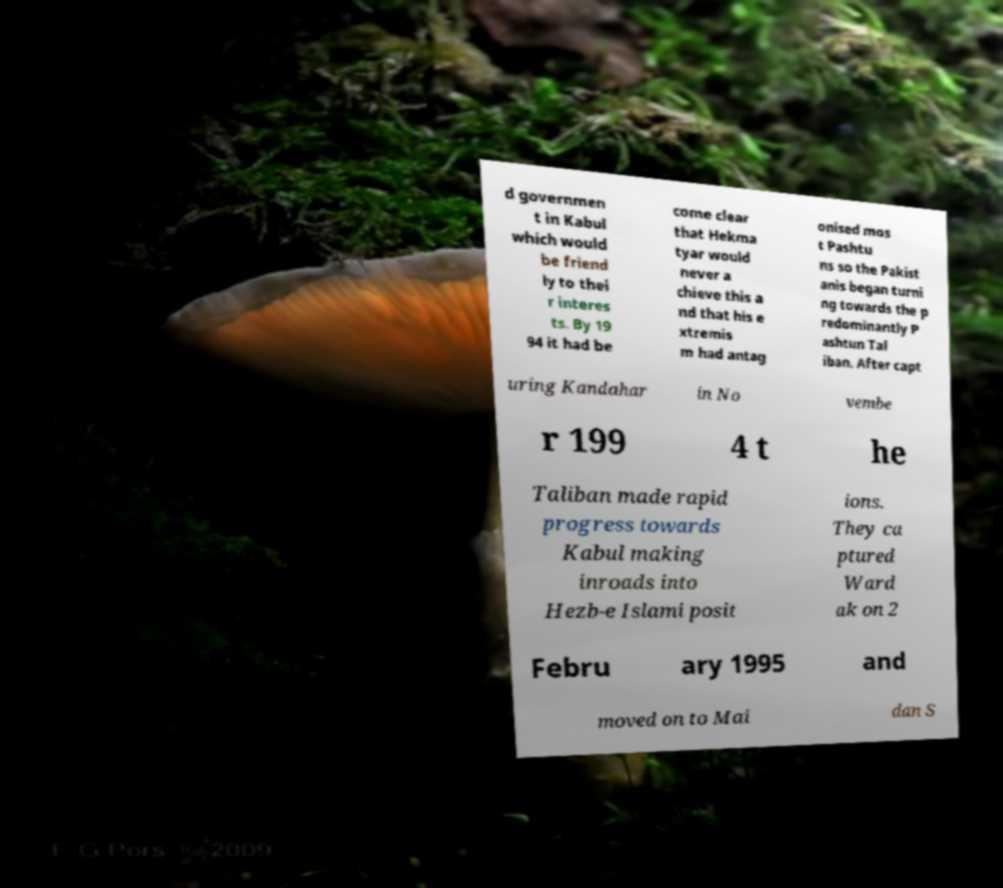Please read and relay the text visible in this image. What does it say? d governmen t in Kabul which would be friend ly to thei r interes ts. By 19 94 it had be come clear that Hekma tyar would never a chieve this a nd that his e xtremis m had antag onised mos t Pashtu ns so the Pakist anis began turni ng towards the p redominantly P ashtun Tal iban. After capt uring Kandahar in No vembe r 199 4 t he Taliban made rapid progress towards Kabul making inroads into Hezb-e Islami posit ions. They ca ptured Ward ak on 2 Febru ary 1995 and moved on to Mai dan S 